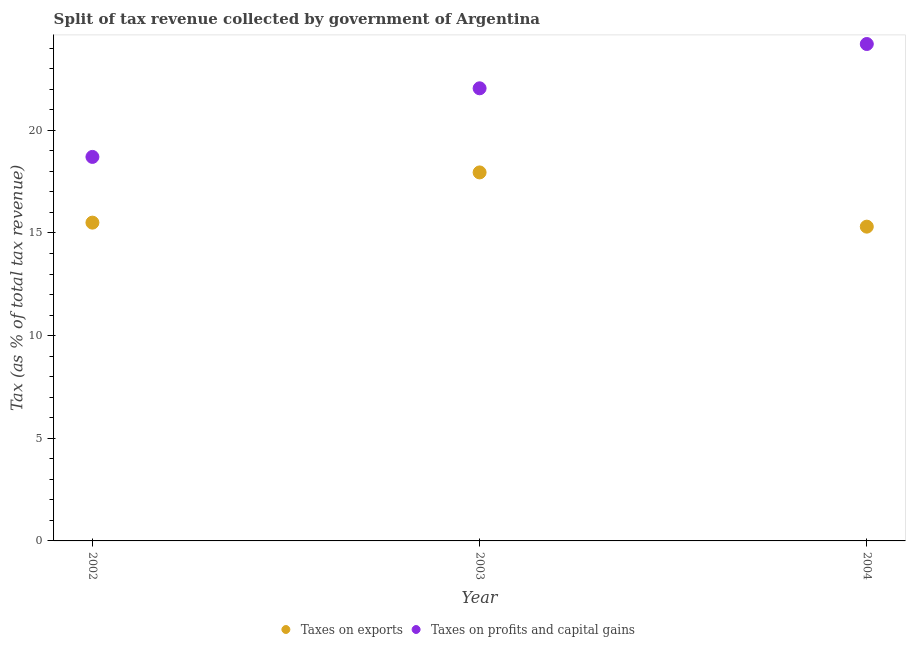How many different coloured dotlines are there?
Provide a short and direct response. 2. Is the number of dotlines equal to the number of legend labels?
Your response must be concise. Yes. What is the percentage of revenue obtained from taxes on profits and capital gains in 2004?
Your answer should be very brief. 24.2. Across all years, what is the maximum percentage of revenue obtained from taxes on profits and capital gains?
Provide a succinct answer. 24.2. Across all years, what is the minimum percentage of revenue obtained from taxes on profits and capital gains?
Offer a very short reply. 18.7. In which year was the percentage of revenue obtained from taxes on exports maximum?
Make the answer very short. 2003. What is the total percentage of revenue obtained from taxes on profits and capital gains in the graph?
Keep it short and to the point. 64.95. What is the difference between the percentage of revenue obtained from taxes on exports in 2003 and that in 2004?
Provide a short and direct response. 2.64. What is the difference between the percentage of revenue obtained from taxes on profits and capital gains in 2003 and the percentage of revenue obtained from taxes on exports in 2004?
Your answer should be compact. 6.74. What is the average percentage of revenue obtained from taxes on exports per year?
Give a very brief answer. 16.25. In the year 2003, what is the difference between the percentage of revenue obtained from taxes on profits and capital gains and percentage of revenue obtained from taxes on exports?
Give a very brief answer. 4.1. What is the ratio of the percentage of revenue obtained from taxes on profits and capital gains in 2002 to that in 2004?
Give a very brief answer. 0.77. What is the difference between the highest and the second highest percentage of revenue obtained from taxes on profits and capital gains?
Your answer should be very brief. 2.16. What is the difference between the highest and the lowest percentage of revenue obtained from taxes on exports?
Ensure brevity in your answer.  2.64. Does the percentage of revenue obtained from taxes on profits and capital gains monotonically increase over the years?
Provide a succinct answer. Yes. How many years are there in the graph?
Give a very brief answer. 3. Does the graph contain grids?
Provide a short and direct response. No. How many legend labels are there?
Offer a terse response. 2. How are the legend labels stacked?
Your answer should be compact. Horizontal. What is the title of the graph?
Provide a succinct answer. Split of tax revenue collected by government of Argentina. What is the label or title of the X-axis?
Ensure brevity in your answer.  Year. What is the label or title of the Y-axis?
Keep it short and to the point. Tax (as % of total tax revenue). What is the Tax (as % of total tax revenue) of Taxes on exports in 2002?
Provide a succinct answer. 15.5. What is the Tax (as % of total tax revenue) of Taxes on profits and capital gains in 2002?
Provide a succinct answer. 18.7. What is the Tax (as % of total tax revenue) in Taxes on exports in 2003?
Ensure brevity in your answer.  17.95. What is the Tax (as % of total tax revenue) in Taxes on profits and capital gains in 2003?
Your answer should be compact. 22.05. What is the Tax (as % of total tax revenue) in Taxes on exports in 2004?
Offer a very short reply. 15.31. What is the Tax (as % of total tax revenue) in Taxes on profits and capital gains in 2004?
Offer a very short reply. 24.2. Across all years, what is the maximum Tax (as % of total tax revenue) of Taxes on exports?
Ensure brevity in your answer.  17.95. Across all years, what is the maximum Tax (as % of total tax revenue) of Taxes on profits and capital gains?
Make the answer very short. 24.2. Across all years, what is the minimum Tax (as % of total tax revenue) in Taxes on exports?
Make the answer very short. 15.31. Across all years, what is the minimum Tax (as % of total tax revenue) in Taxes on profits and capital gains?
Your response must be concise. 18.7. What is the total Tax (as % of total tax revenue) in Taxes on exports in the graph?
Ensure brevity in your answer.  48.76. What is the total Tax (as % of total tax revenue) in Taxes on profits and capital gains in the graph?
Ensure brevity in your answer.  64.95. What is the difference between the Tax (as % of total tax revenue) in Taxes on exports in 2002 and that in 2003?
Offer a terse response. -2.45. What is the difference between the Tax (as % of total tax revenue) of Taxes on profits and capital gains in 2002 and that in 2003?
Your answer should be compact. -3.34. What is the difference between the Tax (as % of total tax revenue) in Taxes on exports in 2002 and that in 2004?
Keep it short and to the point. 0.2. What is the difference between the Tax (as % of total tax revenue) of Taxes on profits and capital gains in 2002 and that in 2004?
Keep it short and to the point. -5.5. What is the difference between the Tax (as % of total tax revenue) in Taxes on exports in 2003 and that in 2004?
Your response must be concise. 2.64. What is the difference between the Tax (as % of total tax revenue) in Taxes on profits and capital gains in 2003 and that in 2004?
Ensure brevity in your answer.  -2.16. What is the difference between the Tax (as % of total tax revenue) of Taxes on exports in 2002 and the Tax (as % of total tax revenue) of Taxes on profits and capital gains in 2003?
Your answer should be very brief. -6.54. What is the difference between the Tax (as % of total tax revenue) in Taxes on exports in 2002 and the Tax (as % of total tax revenue) in Taxes on profits and capital gains in 2004?
Your response must be concise. -8.7. What is the difference between the Tax (as % of total tax revenue) in Taxes on exports in 2003 and the Tax (as % of total tax revenue) in Taxes on profits and capital gains in 2004?
Keep it short and to the point. -6.25. What is the average Tax (as % of total tax revenue) in Taxes on exports per year?
Provide a short and direct response. 16.25. What is the average Tax (as % of total tax revenue) of Taxes on profits and capital gains per year?
Your answer should be very brief. 21.65. In the year 2002, what is the difference between the Tax (as % of total tax revenue) in Taxes on exports and Tax (as % of total tax revenue) in Taxes on profits and capital gains?
Give a very brief answer. -3.2. In the year 2003, what is the difference between the Tax (as % of total tax revenue) in Taxes on exports and Tax (as % of total tax revenue) in Taxes on profits and capital gains?
Ensure brevity in your answer.  -4.1. In the year 2004, what is the difference between the Tax (as % of total tax revenue) in Taxes on exports and Tax (as % of total tax revenue) in Taxes on profits and capital gains?
Your response must be concise. -8.9. What is the ratio of the Tax (as % of total tax revenue) in Taxes on exports in 2002 to that in 2003?
Your answer should be compact. 0.86. What is the ratio of the Tax (as % of total tax revenue) in Taxes on profits and capital gains in 2002 to that in 2003?
Offer a very short reply. 0.85. What is the ratio of the Tax (as % of total tax revenue) of Taxes on exports in 2002 to that in 2004?
Your response must be concise. 1.01. What is the ratio of the Tax (as % of total tax revenue) of Taxes on profits and capital gains in 2002 to that in 2004?
Give a very brief answer. 0.77. What is the ratio of the Tax (as % of total tax revenue) in Taxes on exports in 2003 to that in 2004?
Keep it short and to the point. 1.17. What is the ratio of the Tax (as % of total tax revenue) in Taxes on profits and capital gains in 2003 to that in 2004?
Your response must be concise. 0.91. What is the difference between the highest and the second highest Tax (as % of total tax revenue) in Taxes on exports?
Your answer should be compact. 2.45. What is the difference between the highest and the second highest Tax (as % of total tax revenue) in Taxes on profits and capital gains?
Make the answer very short. 2.16. What is the difference between the highest and the lowest Tax (as % of total tax revenue) of Taxes on exports?
Your answer should be compact. 2.64. What is the difference between the highest and the lowest Tax (as % of total tax revenue) of Taxes on profits and capital gains?
Give a very brief answer. 5.5. 